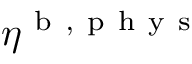Convert formula to latex. <formula><loc_0><loc_0><loc_500><loc_500>\eta ^ { b , p h y s }</formula> 